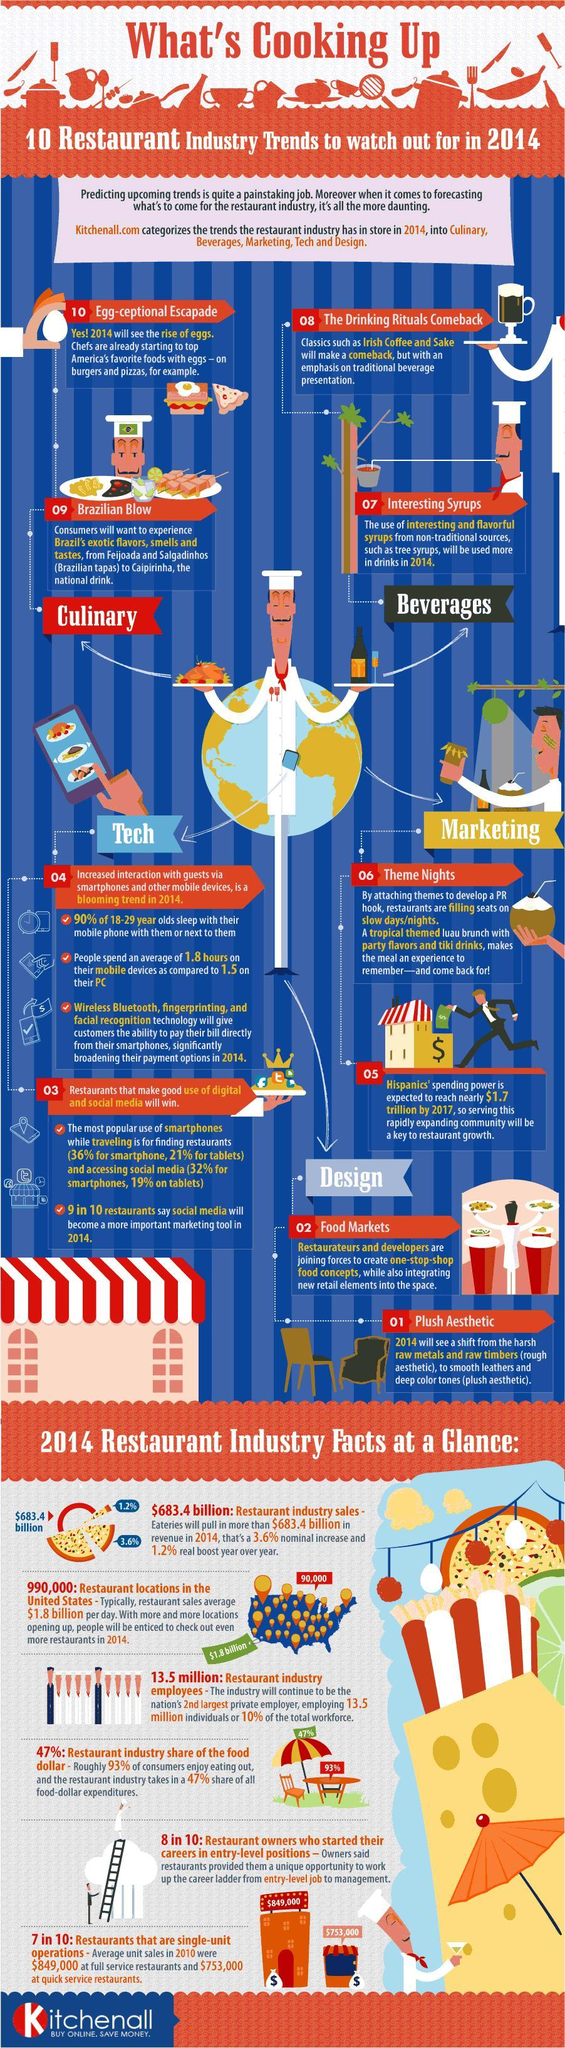Average hours spend for which on is higher - PC or smart phone?
Answer the question with a short phrase. smart phone What are the design trends in restaurant industry about? food markets, plush aesthetics what is the percentage of restaurants that does not operate as a single unit? 30% what are the three technologies that may help costumers to pay the bills in 2014? wireless Bluetooth, finger printing how many restaurant industry facts are given in bottom section of this infographic? 6 What percent of 18-29 years old sleep without smart phone near them? 10 what is the color of the text "what's cooking up" - orange or white? orange What are the two trends in restaurant industry given that are about beverages? the drinking rituals comeback, interesting syrups what is the percentage of restaurant owners who did not start their career in entry level? 20 How many more hours people spend on smart phones than PCs on and average? 0.3 